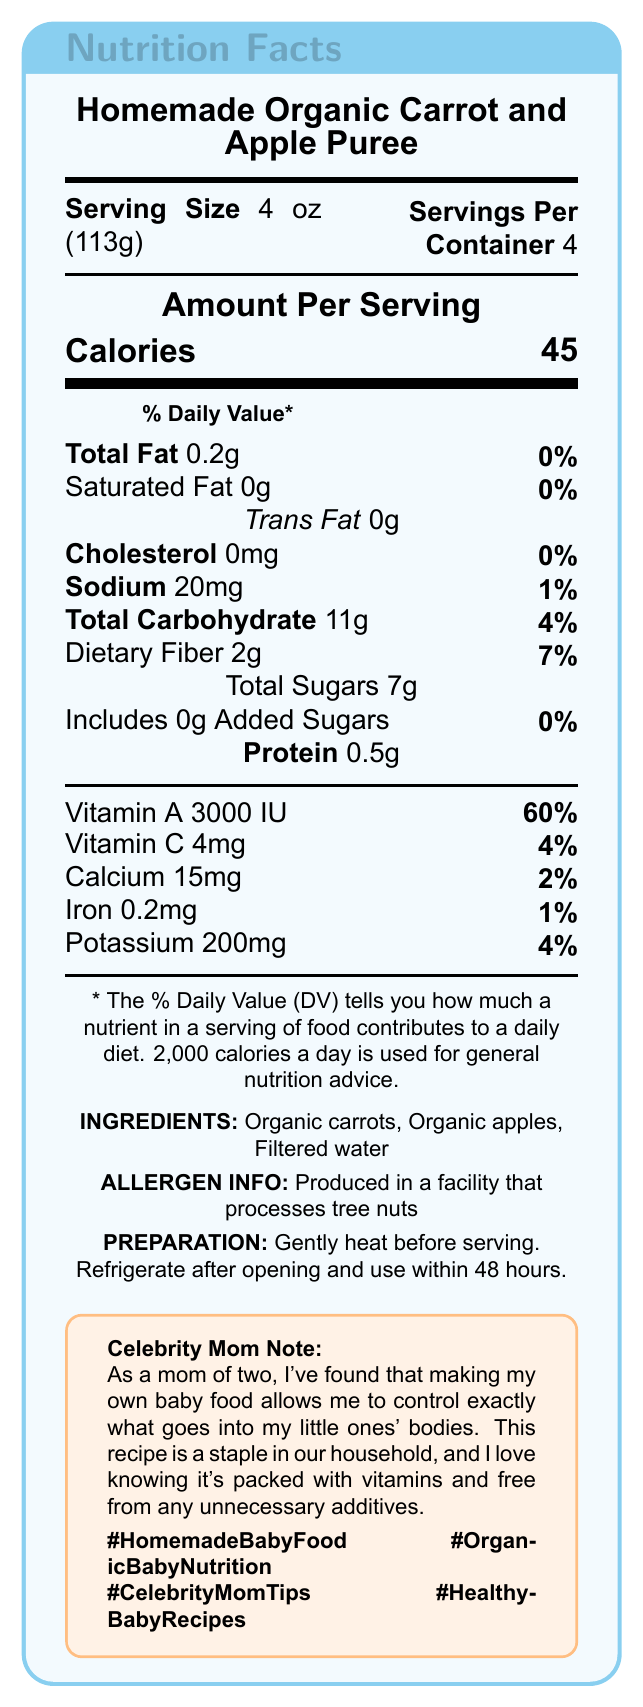what is the serving size? The document clearly states the serving size as "4 oz (113g)".
Answer: 4 oz (113g) how many servings are in one container? The document mentions "Servings Per Container" as 4.
Answer: 4 servings what is the amount of total fat per serving? The total fat per serving is shown as 0.2g in the document.
Answer: 0.2g how much dietary fiber is in one serving? The document lists 2g of dietary fiber per serving.
Answer: 2g what ingredients are used in the homemade puree? The ingredients listed in the document are "Organic carrots, Organic apples, Filtered water".
Answer: Organic carrots, Organic apples, Filtered water how much vitamin A does one serving provide? A. 300 IU B. 3000 IU C. 1500 IU D. 1000 IU The document states that one serving provides 3000 IU of Vitamin A.
Answer: B how much sodium is in one serving? A. 10mg B. 50mg C. 75mg D. 20mg The document shows the sodium content per serving as 20mg.
Answer: D does this homemade puree contain any added sugars? The document states that there are 0g of added sugars per serving.
Answer: No is the homemade puree free from preservatives? The document mentions that the puree contains no preservatives and highlights this in the comparison to the store-bought option.
Answer: Yes compare the calories of the homemade puree to the store-bought one. The document mentions that the store-bought puree contains 5 more calories than the homemade one.
Answer: +5 calories for the store-bought option summarize the main difference between the homemade puree and the store-bought option This summary captures the key nutritional and ingredient differences highlighted in the document.
Answer: The homemade organic carrot and apple puree boasts fewer calories, less total sugar, and less sodium than the store-bought option (Gerber Organic 2nd Foods Carrot Apple Pear). Additionally, the homemade puree offers more Vitamin A and contains no preservatives, while the store-bought option includes ascorbic acid. how should the homemade puree be stored after opening? The document advises to refrigerate after opening and use within 48 hours.
Answer: Refrigerate and use within 48 hours who provided the celebrity mom note? The document refers to a "celebrity mom" note but does not specify the name, so the answer is not available.
Answer: The document does not specify the name of the celebrity mom. how many grams of protein are in one serving? The document lists 0.5g of protein per serving.
Answer: 0.5g what is the daily value percentage of iron provided by one serving? The document specifies that one serving provides 1% of the daily value of iron.
Answer: 1% which hashtag is mentioned in the document? A. #RightBabyFood B. #OrganicFood C. #HealthyBabyRecipes D. #MommyTips The hashtag #HealthyBabyRecipes is explicitly mentioned in the document.
Answer: C 